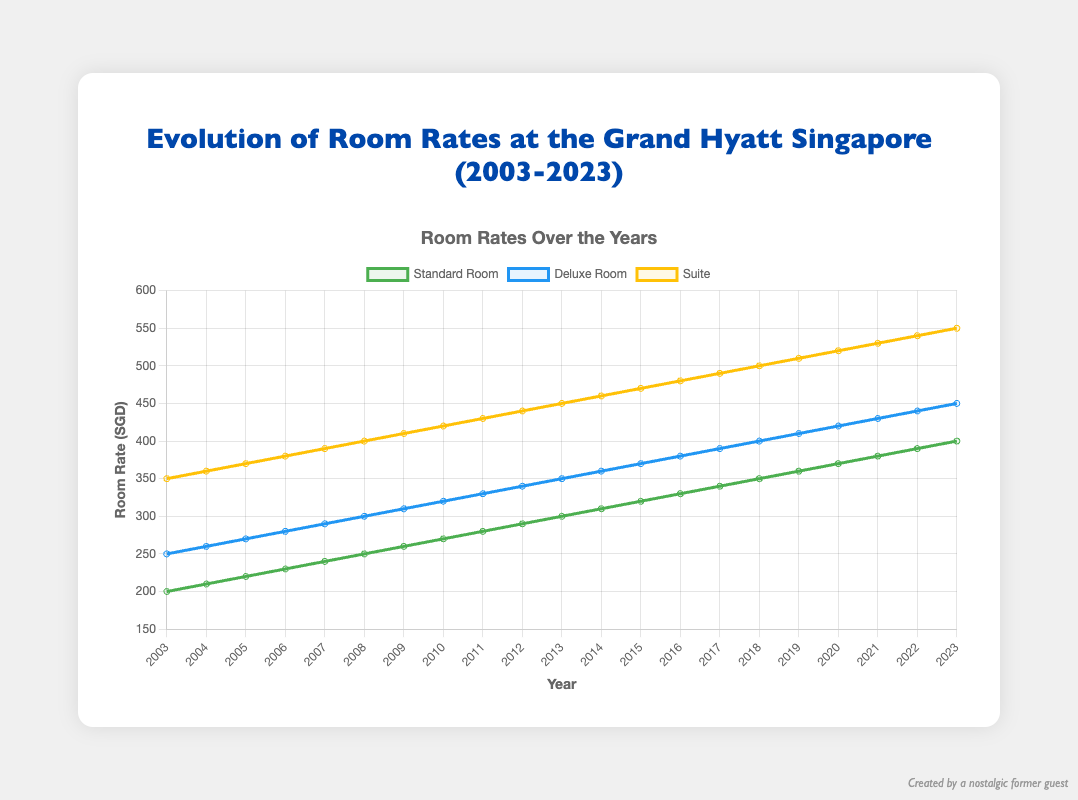What was the standard room rate in 2003? According to the line plot, the rate for a standard room in 2003 can be identified at the leftmost point of the green line.
Answer: 200 By how much did the deluxe room rate increase from 2003 to 2023? The plot shows the initial rate for the deluxe room in 2003 and the final rate in 2023. Subtract the value of 2003 from that of 2023: 450 - 250.
Answer: 200 What year did the suite room rate reach 500 SGD? We need to find the point on the yellow line that corresponds to 500 on the y-axis and identify the corresponding year on the x-axis.
Answer: 2018 Which year saw the highest increase in the standard room rate compared to the previous year? To find this, observe the green line and identify the segments with the steepest slopes. Verify yearly increments visually.
Answer: 2013 On average, by how much did the deluxe room rate increase per year over the two decades? Calculate the total increase over 20 years and then divide by the number of years: (450 - 250) / 20.
Answer: 10 In 2010, which room type had the highest rate, and what was it? Refer to the points on the graph corresponding to the year 2010 and compare the rates of the three room types. The suite room rate (orange line) is the highest.
Answer: Suite, 420 What is the sum of the standard room rates in the years 2020, 2021, and 2022? Add the standard room rates for the years 2020, 2021, and 2022: 370 + 380 + 390 = 1140.
Answer: 1140 Did the deluxe room rate ever decrease during the 20-year period? Inspect the blue line from left to right to check if there is any downward slope over any intervals.
Answer: No How does the rate of increase in the standard room rate compare to that of the deluxe room rate? Analyze the slopes of green and blue lines. Both lines have nearly equal upward trends, suggesting similar rate increases.
Answer: Similar Which year saw the smallest gap between the standard room rate and the suite room rate? Find the smallest vertical distance between the green and yellow lines over the years, focusing on 2011 when the difference was minimal: 430 - 280 = 150.
Answer: 2011 